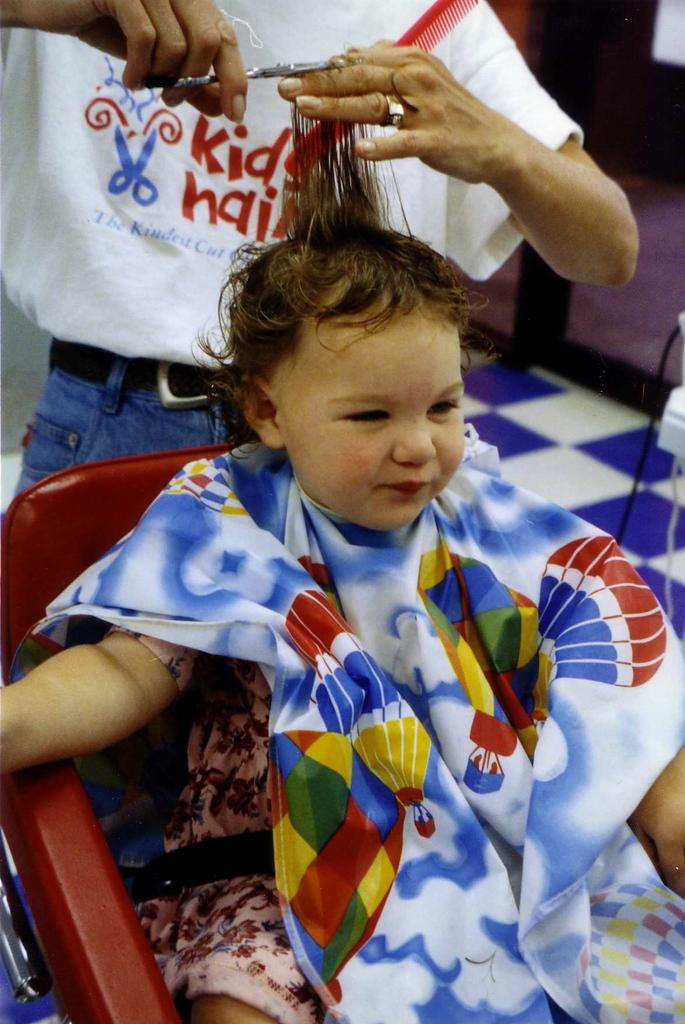What is: What is the kid doing in the image? The kid is sitting on a chair in the image. What is the kid wearing? The kid is wearing clothes in the image. Who is standing behind the kid? There is a person standing behind the kid in the image. What is the person holding? The person is holding scissors and hair in the image. What is visible beneath the kid and the person? There is a floor visible in the image. What type of credit can be seen being given to the kid in the image? There is no credit being given to the kid in the image; it is not a financial or academic context. 